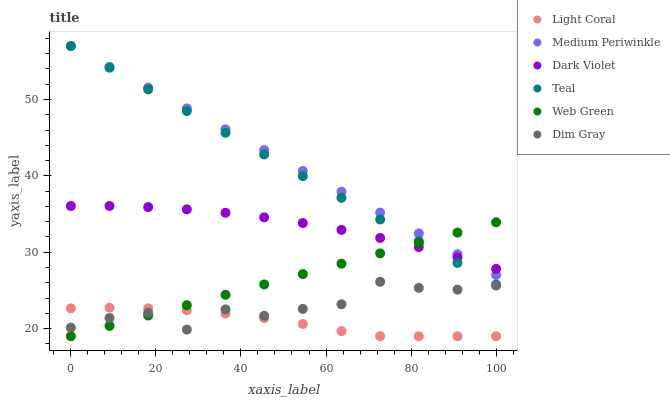Does Light Coral have the minimum area under the curve?
Answer yes or no. Yes. Does Medium Periwinkle have the maximum area under the curve?
Answer yes or no. Yes. Does Web Green have the minimum area under the curve?
Answer yes or no. No. Does Web Green have the maximum area under the curve?
Answer yes or no. No. Is Web Green the smoothest?
Answer yes or no. Yes. Is Dim Gray the roughest?
Answer yes or no. Yes. Is Medium Periwinkle the smoothest?
Answer yes or no. No. Is Medium Periwinkle the roughest?
Answer yes or no. No. Does Web Green have the lowest value?
Answer yes or no. Yes. Does Medium Periwinkle have the lowest value?
Answer yes or no. No. Does Teal have the highest value?
Answer yes or no. Yes. Does Web Green have the highest value?
Answer yes or no. No. Is Light Coral less than Medium Periwinkle?
Answer yes or no. Yes. Is Dark Violet greater than Light Coral?
Answer yes or no. Yes. Does Web Green intersect Teal?
Answer yes or no. Yes. Is Web Green less than Teal?
Answer yes or no. No. Is Web Green greater than Teal?
Answer yes or no. No. Does Light Coral intersect Medium Periwinkle?
Answer yes or no. No. 